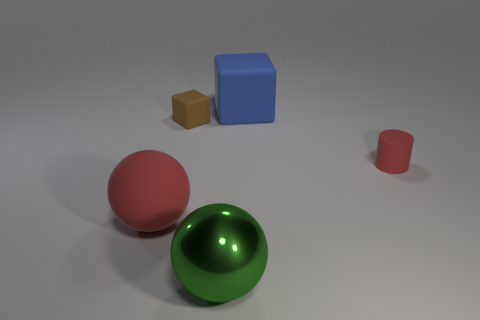Describe the lighting and shadows in the scene. The lighting in the scene is diffused, producing soft shadows that extend diagonally to the left. The gentle shadows suggest an ambient light source above and slightly to the right, enhancing the dimensionality and texture of the objects without creating harsh contrasts. 